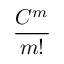Convert formula to latex. <formula><loc_0><loc_0><loc_500><loc_500>\frac { C ^ { m } } { m ! }</formula> 